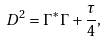<formula> <loc_0><loc_0><loc_500><loc_500>D ^ { 2 } = \Gamma ^ { * } \Gamma + { \frac { \tau } { 4 } } ,</formula> 